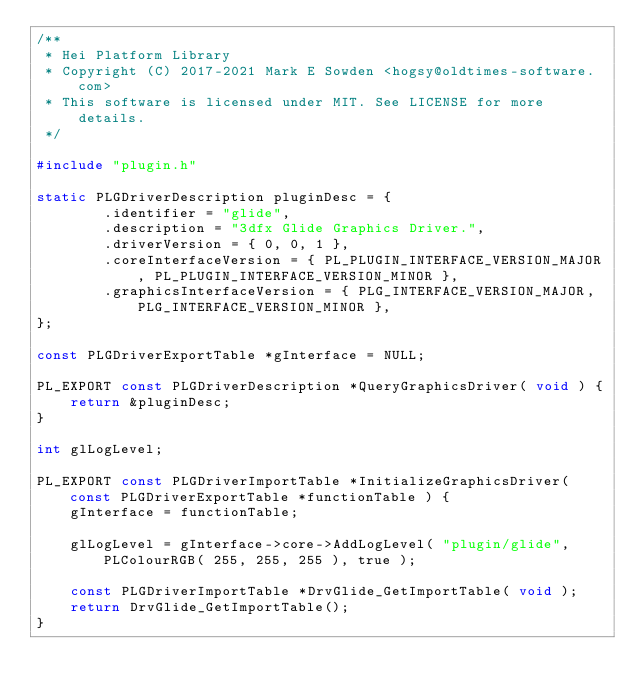<code> <loc_0><loc_0><loc_500><loc_500><_C_>/**
 * Hei Platform Library
 * Copyright (C) 2017-2021 Mark E Sowden <hogsy@oldtimes-software.com>
 * This software is licensed under MIT. See LICENSE for more details.
 */

#include "plugin.h"

static PLGDriverDescription pluginDesc = {
        .identifier = "glide",
        .description = "3dfx Glide Graphics Driver.",
        .driverVersion = { 0, 0, 1 },
        .coreInterfaceVersion = { PL_PLUGIN_INTERFACE_VERSION_MAJOR, PL_PLUGIN_INTERFACE_VERSION_MINOR },
        .graphicsInterfaceVersion = { PLG_INTERFACE_VERSION_MAJOR, PLG_INTERFACE_VERSION_MINOR },
};

const PLGDriverExportTable *gInterface = NULL;

PL_EXPORT const PLGDriverDescription *QueryGraphicsDriver( void ) {
	return &pluginDesc;
}

int glLogLevel;

PL_EXPORT const PLGDriverImportTable *InitializeGraphicsDriver( const PLGDriverExportTable *functionTable ) {
	gInterface = functionTable;

	glLogLevel = gInterface->core->AddLogLevel( "plugin/glide", PLColourRGB( 255, 255, 255 ), true );

	const PLGDriverImportTable *DrvGlide_GetImportTable( void );
	return DrvGlide_GetImportTable();
}
</code> 